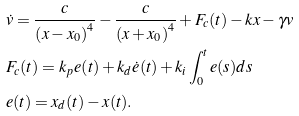<formula> <loc_0><loc_0><loc_500><loc_500>& \dot { v } = \frac { c } { \left ( x - x _ { 0 } \right ) ^ { 4 } } - \frac { c } { \left ( x + x _ { 0 } \right ) ^ { 4 } } + F _ { c } ( t ) - k x - \gamma v \\ & F _ { c } ( t ) = k _ { p } e ( t ) + k _ { d } \dot { e } ( t ) + k _ { i } \int _ { 0 } ^ { t } e ( s ) d s \\ & e ( t ) = x _ { d } ( t ) - x ( t ) .</formula> 